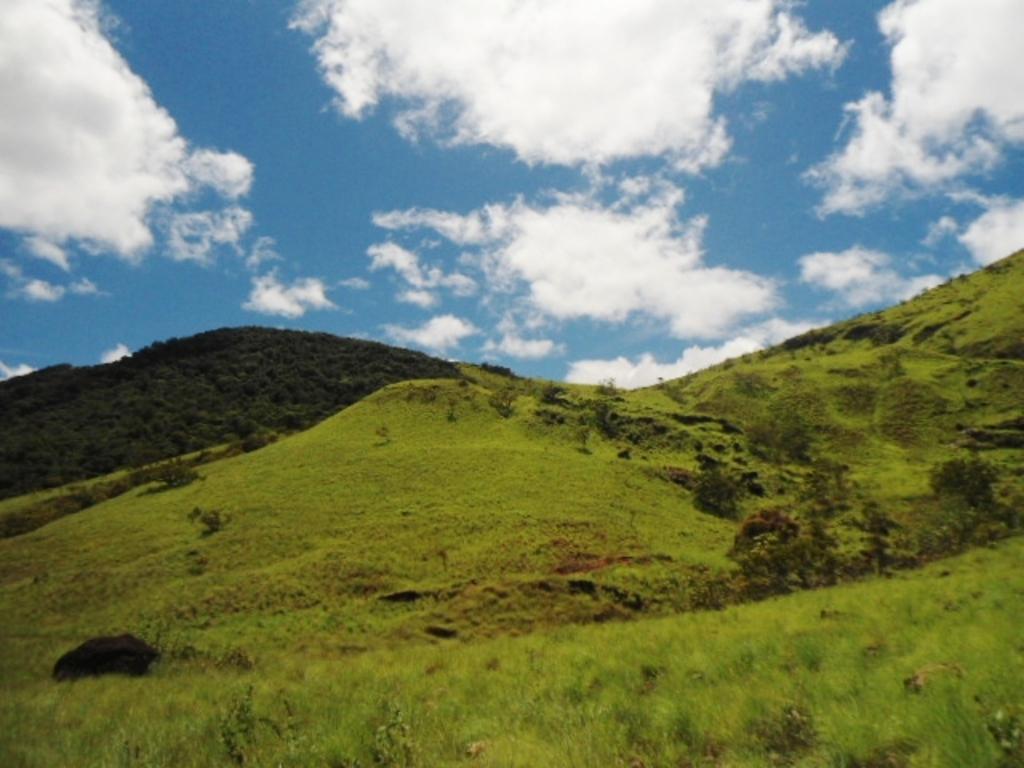Could you give a brief overview of what you see in this image? In this picture we can see grass, few trees and hills, in the background we can see clouds. 